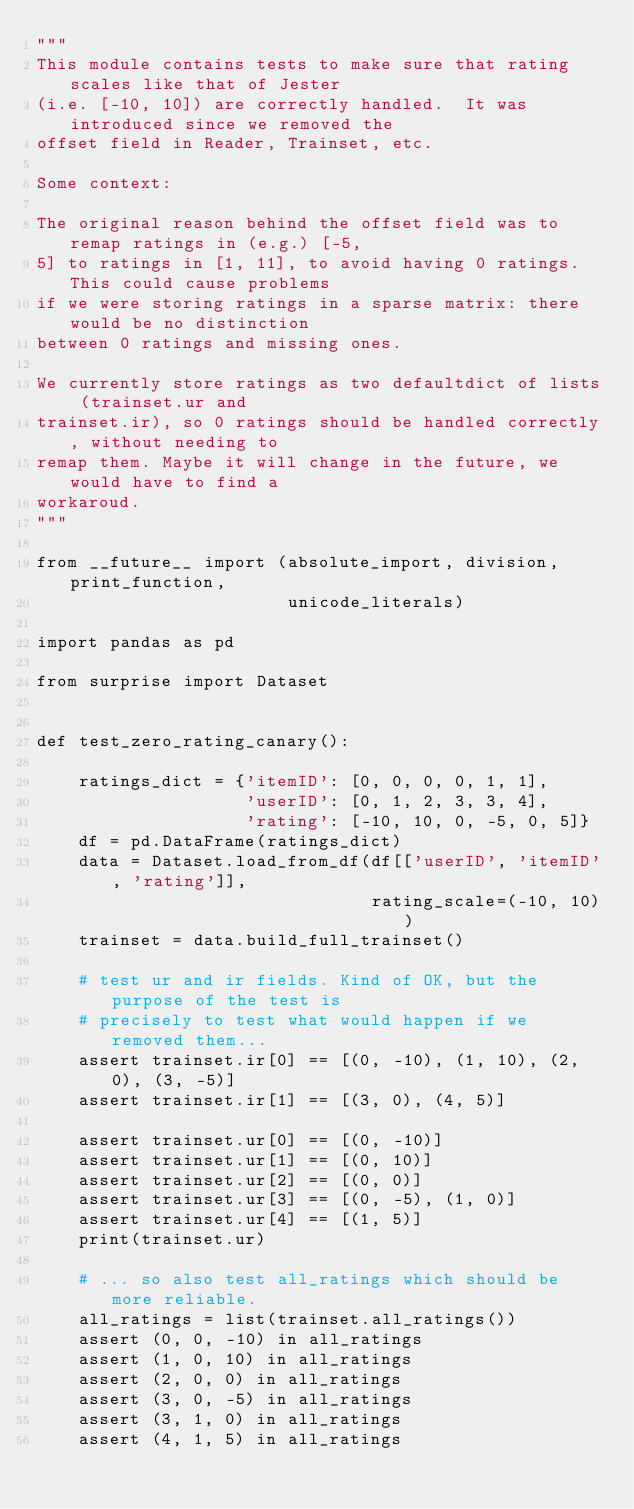Convert code to text. <code><loc_0><loc_0><loc_500><loc_500><_Python_>"""
This module contains tests to make sure that rating scales like that of Jester
(i.e. [-10, 10]) are correctly handled.  It was introduced since we removed the
offset field in Reader, Trainset, etc.

Some context:

The original reason behind the offset field was to remap ratings in (e.g.) [-5,
5] to ratings in [1, 11], to avoid having 0 ratings. This could cause problems
if we were storing ratings in a sparse matrix: there would be no distinction
between 0 ratings and missing ones.

We currently store ratings as two defaultdict of lists (trainset.ur and
trainset.ir), so 0 ratings should be handled correctly, without needing to
remap them. Maybe it will change in the future, we would have to find a
workaroud.
"""

from __future__ import (absolute_import, division, print_function,
                        unicode_literals)

import pandas as pd

from surprise import Dataset


def test_zero_rating_canary():

    ratings_dict = {'itemID': [0, 0, 0, 0, 1, 1],
                    'userID': [0, 1, 2, 3, 3, 4],
                    'rating': [-10, 10, 0, -5, 0, 5]}
    df = pd.DataFrame(ratings_dict)
    data = Dataset.load_from_df(df[['userID', 'itemID', 'rating']],
                                rating_scale=(-10, 10))
    trainset = data.build_full_trainset()

    # test ur and ir fields. Kind of OK, but the purpose of the test is
    # precisely to test what would happen if we removed them...
    assert trainset.ir[0] == [(0, -10), (1, 10), (2, 0), (3, -5)]
    assert trainset.ir[1] == [(3, 0), (4, 5)]

    assert trainset.ur[0] == [(0, -10)]
    assert trainset.ur[1] == [(0, 10)]
    assert trainset.ur[2] == [(0, 0)]
    assert trainset.ur[3] == [(0, -5), (1, 0)]
    assert trainset.ur[4] == [(1, 5)]
    print(trainset.ur)

    # ... so also test all_ratings which should be more reliable.
    all_ratings = list(trainset.all_ratings())
    assert (0, 0, -10) in all_ratings
    assert (1, 0, 10) in all_ratings
    assert (2, 0, 0) in all_ratings
    assert (3, 0, -5) in all_ratings
    assert (3, 1, 0) in all_ratings
    assert (4, 1, 5) in all_ratings
</code> 